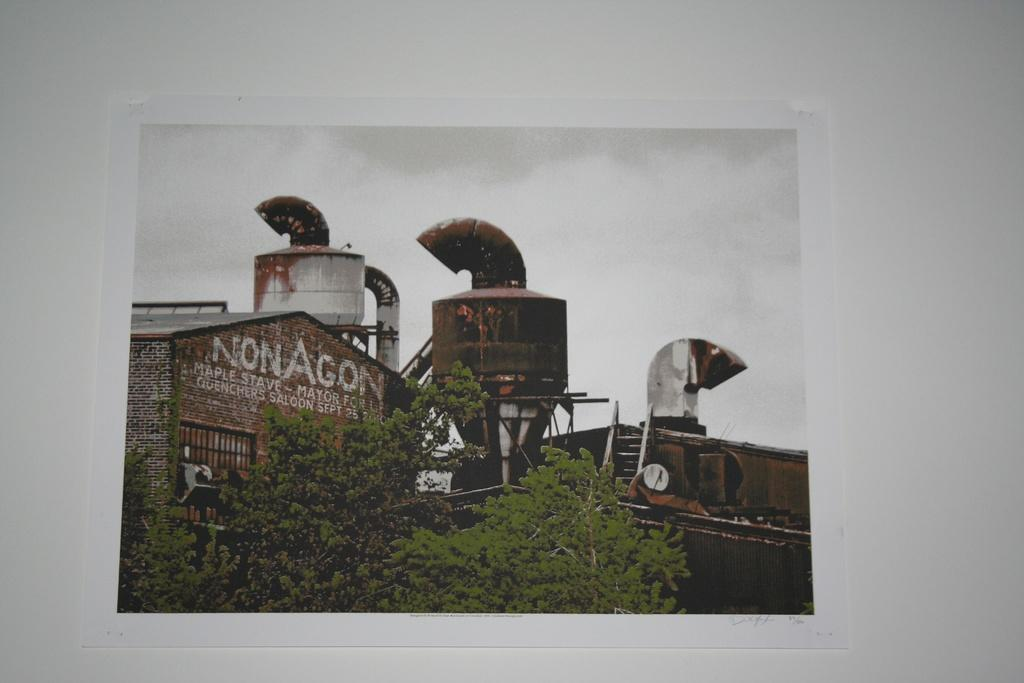Provide a one-sentence caption for the provided image. a building with the word nonagon at the top of it. 